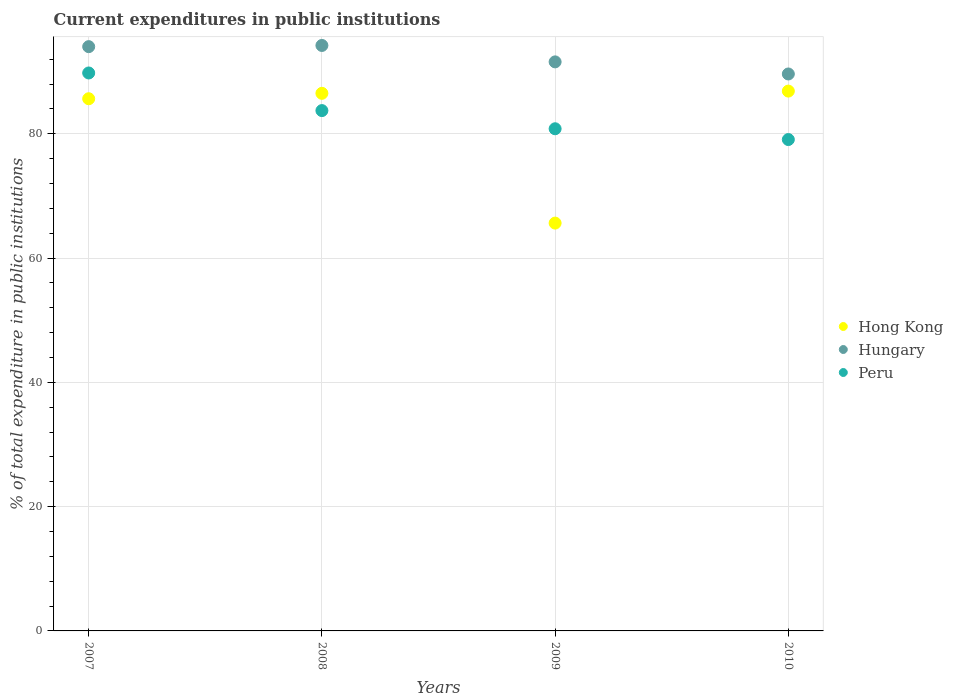Is the number of dotlines equal to the number of legend labels?
Your answer should be compact. Yes. What is the current expenditures in public institutions in Hungary in 2010?
Provide a short and direct response. 89.63. Across all years, what is the maximum current expenditures in public institutions in Peru?
Provide a short and direct response. 89.79. Across all years, what is the minimum current expenditures in public institutions in Peru?
Your response must be concise. 79.08. In which year was the current expenditures in public institutions in Hungary maximum?
Provide a short and direct response. 2008. What is the total current expenditures in public institutions in Hong Kong in the graph?
Provide a succinct answer. 324.67. What is the difference between the current expenditures in public institutions in Hungary in 2007 and that in 2010?
Your answer should be very brief. 4.4. What is the difference between the current expenditures in public institutions in Hungary in 2010 and the current expenditures in public institutions in Peru in 2009?
Offer a very short reply. 8.82. What is the average current expenditures in public institutions in Hong Kong per year?
Ensure brevity in your answer.  81.17. In the year 2009, what is the difference between the current expenditures in public institutions in Peru and current expenditures in public institutions in Hong Kong?
Give a very brief answer. 15.18. In how many years, is the current expenditures in public institutions in Hong Kong greater than 28 %?
Your answer should be very brief. 4. What is the ratio of the current expenditures in public institutions in Hong Kong in 2008 to that in 2010?
Provide a succinct answer. 1. What is the difference between the highest and the second highest current expenditures in public institutions in Hungary?
Ensure brevity in your answer.  0.19. What is the difference between the highest and the lowest current expenditures in public institutions in Hong Kong?
Offer a very short reply. 21.24. In how many years, is the current expenditures in public institutions in Hungary greater than the average current expenditures in public institutions in Hungary taken over all years?
Keep it short and to the point. 2. Is the current expenditures in public institutions in Peru strictly greater than the current expenditures in public institutions in Hungary over the years?
Provide a succinct answer. No. How many dotlines are there?
Provide a short and direct response. 3. How many years are there in the graph?
Offer a very short reply. 4. Does the graph contain any zero values?
Keep it short and to the point. No. Does the graph contain grids?
Your response must be concise. Yes. Where does the legend appear in the graph?
Your answer should be very brief. Center right. How many legend labels are there?
Offer a very short reply. 3. What is the title of the graph?
Give a very brief answer. Current expenditures in public institutions. What is the label or title of the Y-axis?
Your answer should be compact. % of total expenditure in public institutions. What is the % of total expenditure in public institutions in Hong Kong in 2007?
Keep it short and to the point. 85.65. What is the % of total expenditure in public institutions in Hungary in 2007?
Keep it short and to the point. 94.03. What is the % of total expenditure in public institutions in Peru in 2007?
Provide a short and direct response. 89.79. What is the % of total expenditure in public institutions of Hong Kong in 2008?
Ensure brevity in your answer.  86.52. What is the % of total expenditure in public institutions of Hungary in 2008?
Your response must be concise. 94.22. What is the % of total expenditure in public institutions in Peru in 2008?
Your answer should be very brief. 83.74. What is the % of total expenditure in public institutions in Hong Kong in 2009?
Give a very brief answer. 65.63. What is the % of total expenditure in public institutions of Hungary in 2009?
Give a very brief answer. 91.58. What is the % of total expenditure in public institutions in Peru in 2009?
Ensure brevity in your answer.  80.81. What is the % of total expenditure in public institutions in Hong Kong in 2010?
Ensure brevity in your answer.  86.88. What is the % of total expenditure in public institutions in Hungary in 2010?
Your answer should be very brief. 89.63. What is the % of total expenditure in public institutions of Peru in 2010?
Your answer should be compact. 79.08. Across all years, what is the maximum % of total expenditure in public institutions of Hong Kong?
Offer a very short reply. 86.88. Across all years, what is the maximum % of total expenditure in public institutions of Hungary?
Your answer should be compact. 94.22. Across all years, what is the maximum % of total expenditure in public institutions in Peru?
Your response must be concise. 89.79. Across all years, what is the minimum % of total expenditure in public institutions in Hong Kong?
Your answer should be very brief. 65.63. Across all years, what is the minimum % of total expenditure in public institutions in Hungary?
Your answer should be compact. 89.63. Across all years, what is the minimum % of total expenditure in public institutions of Peru?
Provide a succinct answer. 79.08. What is the total % of total expenditure in public institutions of Hong Kong in the graph?
Your response must be concise. 324.67. What is the total % of total expenditure in public institutions in Hungary in the graph?
Your answer should be compact. 369.46. What is the total % of total expenditure in public institutions in Peru in the graph?
Give a very brief answer. 333.42. What is the difference between the % of total expenditure in public institutions in Hong Kong in 2007 and that in 2008?
Ensure brevity in your answer.  -0.87. What is the difference between the % of total expenditure in public institutions in Hungary in 2007 and that in 2008?
Your answer should be very brief. -0.19. What is the difference between the % of total expenditure in public institutions of Peru in 2007 and that in 2008?
Offer a terse response. 6.05. What is the difference between the % of total expenditure in public institutions in Hong Kong in 2007 and that in 2009?
Offer a terse response. 20.01. What is the difference between the % of total expenditure in public institutions in Hungary in 2007 and that in 2009?
Provide a short and direct response. 2.45. What is the difference between the % of total expenditure in public institutions in Peru in 2007 and that in 2009?
Make the answer very short. 8.98. What is the difference between the % of total expenditure in public institutions in Hong Kong in 2007 and that in 2010?
Give a very brief answer. -1.23. What is the difference between the % of total expenditure in public institutions in Hungary in 2007 and that in 2010?
Give a very brief answer. 4.4. What is the difference between the % of total expenditure in public institutions in Peru in 2007 and that in 2010?
Provide a short and direct response. 10.71. What is the difference between the % of total expenditure in public institutions of Hong Kong in 2008 and that in 2009?
Ensure brevity in your answer.  20.89. What is the difference between the % of total expenditure in public institutions in Hungary in 2008 and that in 2009?
Provide a short and direct response. 2.64. What is the difference between the % of total expenditure in public institutions of Peru in 2008 and that in 2009?
Your answer should be compact. 2.92. What is the difference between the % of total expenditure in public institutions in Hong Kong in 2008 and that in 2010?
Provide a succinct answer. -0.36. What is the difference between the % of total expenditure in public institutions of Hungary in 2008 and that in 2010?
Keep it short and to the point. 4.59. What is the difference between the % of total expenditure in public institutions in Peru in 2008 and that in 2010?
Your response must be concise. 4.66. What is the difference between the % of total expenditure in public institutions in Hong Kong in 2009 and that in 2010?
Offer a terse response. -21.24. What is the difference between the % of total expenditure in public institutions in Hungary in 2009 and that in 2010?
Provide a short and direct response. 1.95. What is the difference between the % of total expenditure in public institutions in Peru in 2009 and that in 2010?
Offer a terse response. 1.74. What is the difference between the % of total expenditure in public institutions of Hong Kong in 2007 and the % of total expenditure in public institutions of Hungary in 2008?
Give a very brief answer. -8.57. What is the difference between the % of total expenditure in public institutions in Hong Kong in 2007 and the % of total expenditure in public institutions in Peru in 2008?
Give a very brief answer. 1.91. What is the difference between the % of total expenditure in public institutions of Hungary in 2007 and the % of total expenditure in public institutions of Peru in 2008?
Offer a terse response. 10.29. What is the difference between the % of total expenditure in public institutions in Hong Kong in 2007 and the % of total expenditure in public institutions in Hungary in 2009?
Your answer should be very brief. -5.93. What is the difference between the % of total expenditure in public institutions of Hong Kong in 2007 and the % of total expenditure in public institutions of Peru in 2009?
Your answer should be compact. 4.83. What is the difference between the % of total expenditure in public institutions of Hungary in 2007 and the % of total expenditure in public institutions of Peru in 2009?
Offer a terse response. 13.21. What is the difference between the % of total expenditure in public institutions in Hong Kong in 2007 and the % of total expenditure in public institutions in Hungary in 2010?
Offer a very short reply. -3.99. What is the difference between the % of total expenditure in public institutions of Hong Kong in 2007 and the % of total expenditure in public institutions of Peru in 2010?
Offer a terse response. 6.57. What is the difference between the % of total expenditure in public institutions in Hungary in 2007 and the % of total expenditure in public institutions in Peru in 2010?
Offer a terse response. 14.95. What is the difference between the % of total expenditure in public institutions in Hong Kong in 2008 and the % of total expenditure in public institutions in Hungary in 2009?
Give a very brief answer. -5.06. What is the difference between the % of total expenditure in public institutions of Hong Kong in 2008 and the % of total expenditure in public institutions of Peru in 2009?
Provide a short and direct response. 5.7. What is the difference between the % of total expenditure in public institutions in Hungary in 2008 and the % of total expenditure in public institutions in Peru in 2009?
Ensure brevity in your answer.  13.41. What is the difference between the % of total expenditure in public institutions in Hong Kong in 2008 and the % of total expenditure in public institutions in Hungary in 2010?
Provide a short and direct response. -3.11. What is the difference between the % of total expenditure in public institutions of Hong Kong in 2008 and the % of total expenditure in public institutions of Peru in 2010?
Give a very brief answer. 7.44. What is the difference between the % of total expenditure in public institutions in Hungary in 2008 and the % of total expenditure in public institutions in Peru in 2010?
Your response must be concise. 15.14. What is the difference between the % of total expenditure in public institutions of Hong Kong in 2009 and the % of total expenditure in public institutions of Hungary in 2010?
Provide a succinct answer. -24. What is the difference between the % of total expenditure in public institutions of Hong Kong in 2009 and the % of total expenditure in public institutions of Peru in 2010?
Make the answer very short. -13.45. What is the difference between the % of total expenditure in public institutions of Hungary in 2009 and the % of total expenditure in public institutions of Peru in 2010?
Make the answer very short. 12.5. What is the average % of total expenditure in public institutions of Hong Kong per year?
Your answer should be compact. 81.17. What is the average % of total expenditure in public institutions of Hungary per year?
Keep it short and to the point. 92.36. What is the average % of total expenditure in public institutions in Peru per year?
Provide a short and direct response. 83.35. In the year 2007, what is the difference between the % of total expenditure in public institutions in Hong Kong and % of total expenditure in public institutions in Hungary?
Keep it short and to the point. -8.38. In the year 2007, what is the difference between the % of total expenditure in public institutions in Hong Kong and % of total expenditure in public institutions in Peru?
Ensure brevity in your answer.  -4.15. In the year 2007, what is the difference between the % of total expenditure in public institutions in Hungary and % of total expenditure in public institutions in Peru?
Your answer should be very brief. 4.24. In the year 2008, what is the difference between the % of total expenditure in public institutions in Hong Kong and % of total expenditure in public institutions in Hungary?
Your answer should be compact. -7.7. In the year 2008, what is the difference between the % of total expenditure in public institutions in Hong Kong and % of total expenditure in public institutions in Peru?
Give a very brief answer. 2.78. In the year 2008, what is the difference between the % of total expenditure in public institutions of Hungary and % of total expenditure in public institutions of Peru?
Keep it short and to the point. 10.48. In the year 2009, what is the difference between the % of total expenditure in public institutions of Hong Kong and % of total expenditure in public institutions of Hungary?
Your answer should be very brief. -25.95. In the year 2009, what is the difference between the % of total expenditure in public institutions in Hong Kong and % of total expenditure in public institutions in Peru?
Ensure brevity in your answer.  -15.18. In the year 2009, what is the difference between the % of total expenditure in public institutions in Hungary and % of total expenditure in public institutions in Peru?
Offer a very short reply. 10.76. In the year 2010, what is the difference between the % of total expenditure in public institutions of Hong Kong and % of total expenditure in public institutions of Hungary?
Your answer should be very brief. -2.75. In the year 2010, what is the difference between the % of total expenditure in public institutions in Hong Kong and % of total expenditure in public institutions in Peru?
Offer a very short reply. 7.8. In the year 2010, what is the difference between the % of total expenditure in public institutions of Hungary and % of total expenditure in public institutions of Peru?
Give a very brief answer. 10.55. What is the ratio of the % of total expenditure in public institutions of Hong Kong in 2007 to that in 2008?
Provide a succinct answer. 0.99. What is the ratio of the % of total expenditure in public institutions in Peru in 2007 to that in 2008?
Keep it short and to the point. 1.07. What is the ratio of the % of total expenditure in public institutions in Hong Kong in 2007 to that in 2009?
Offer a terse response. 1.3. What is the ratio of the % of total expenditure in public institutions of Hungary in 2007 to that in 2009?
Your answer should be very brief. 1.03. What is the ratio of the % of total expenditure in public institutions of Peru in 2007 to that in 2009?
Offer a very short reply. 1.11. What is the ratio of the % of total expenditure in public institutions in Hong Kong in 2007 to that in 2010?
Your answer should be compact. 0.99. What is the ratio of the % of total expenditure in public institutions in Hungary in 2007 to that in 2010?
Your answer should be very brief. 1.05. What is the ratio of the % of total expenditure in public institutions in Peru in 2007 to that in 2010?
Your answer should be compact. 1.14. What is the ratio of the % of total expenditure in public institutions in Hong Kong in 2008 to that in 2009?
Offer a very short reply. 1.32. What is the ratio of the % of total expenditure in public institutions in Hungary in 2008 to that in 2009?
Your answer should be compact. 1.03. What is the ratio of the % of total expenditure in public institutions in Peru in 2008 to that in 2009?
Your response must be concise. 1.04. What is the ratio of the % of total expenditure in public institutions of Hong Kong in 2008 to that in 2010?
Keep it short and to the point. 1. What is the ratio of the % of total expenditure in public institutions of Hungary in 2008 to that in 2010?
Ensure brevity in your answer.  1.05. What is the ratio of the % of total expenditure in public institutions in Peru in 2008 to that in 2010?
Ensure brevity in your answer.  1.06. What is the ratio of the % of total expenditure in public institutions of Hong Kong in 2009 to that in 2010?
Ensure brevity in your answer.  0.76. What is the ratio of the % of total expenditure in public institutions of Hungary in 2009 to that in 2010?
Keep it short and to the point. 1.02. What is the ratio of the % of total expenditure in public institutions of Peru in 2009 to that in 2010?
Offer a terse response. 1.02. What is the difference between the highest and the second highest % of total expenditure in public institutions in Hong Kong?
Provide a short and direct response. 0.36. What is the difference between the highest and the second highest % of total expenditure in public institutions in Hungary?
Offer a terse response. 0.19. What is the difference between the highest and the second highest % of total expenditure in public institutions in Peru?
Offer a very short reply. 6.05. What is the difference between the highest and the lowest % of total expenditure in public institutions in Hong Kong?
Make the answer very short. 21.24. What is the difference between the highest and the lowest % of total expenditure in public institutions in Hungary?
Your answer should be very brief. 4.59. What is the difference between the highest and the lowest % of total expenditure in public institutions of Peru?
Keep it short and to the point. 10.71. 